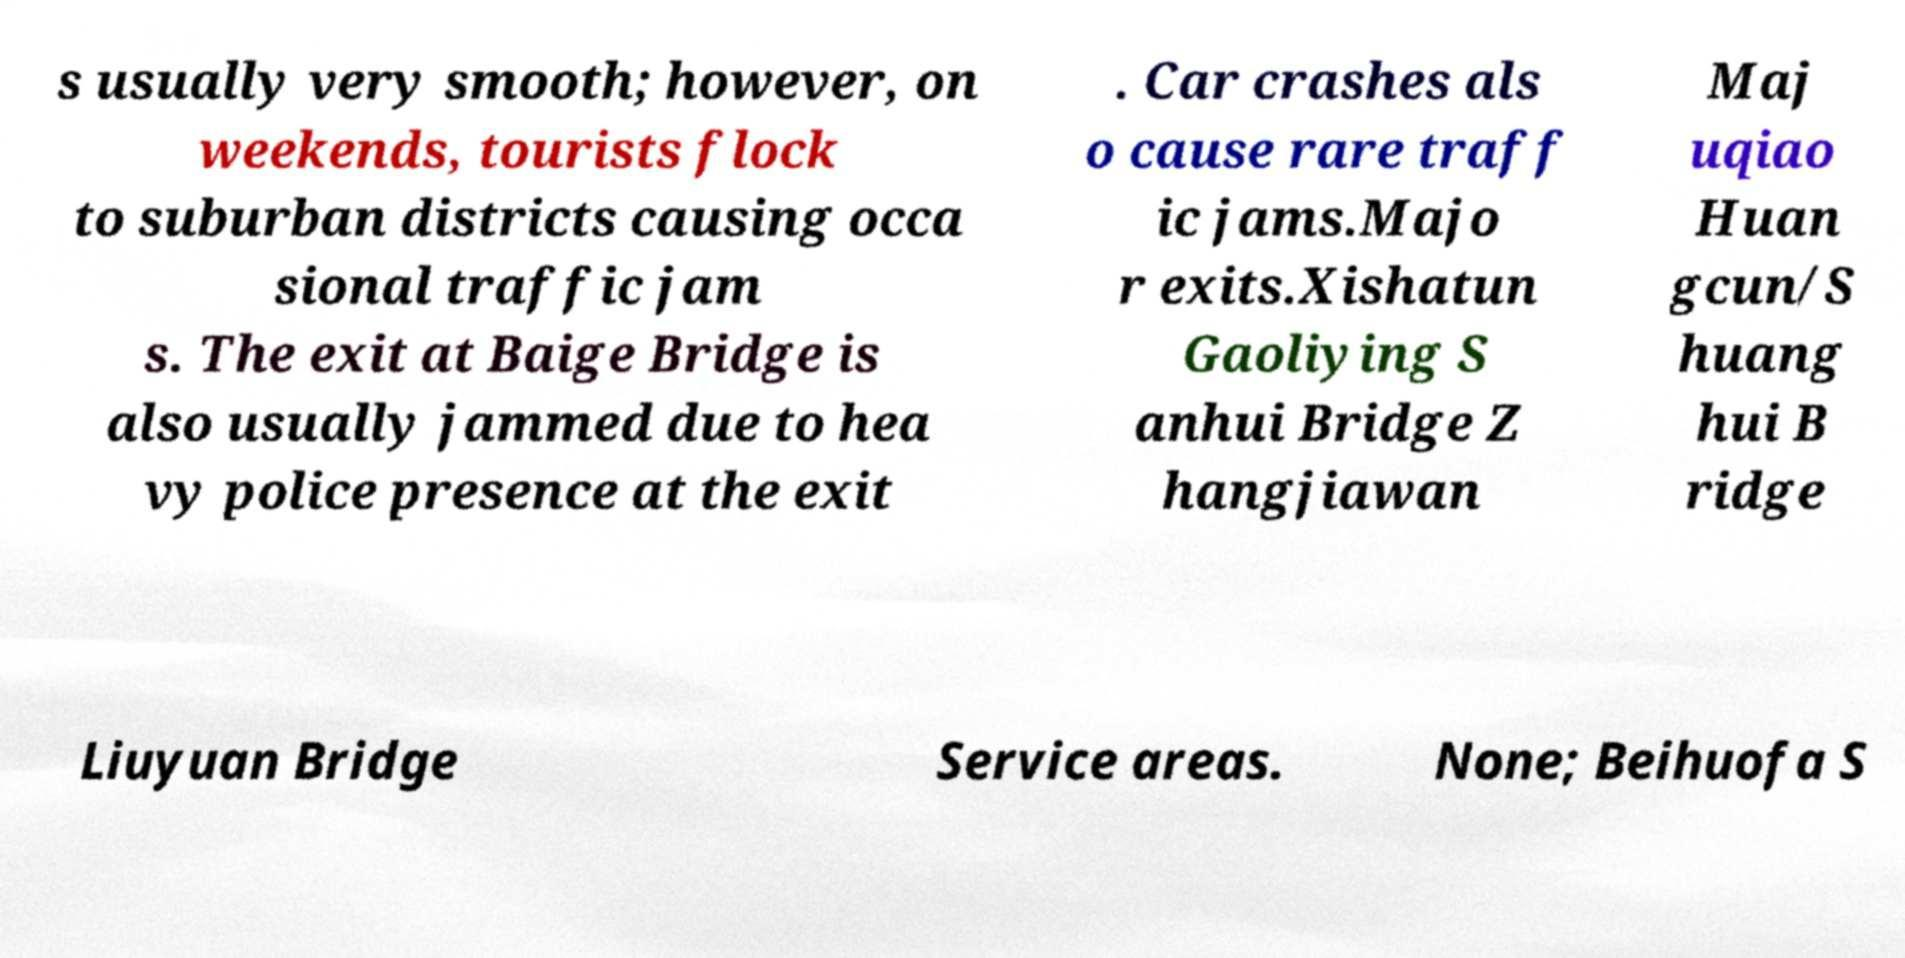Could you assist in decoding the text presented in this image and type it out clearly? s usually very smooth; however, on weekends, tourists flock to suburban districts causing occa sional traffic jam s. The exit at Baige Bridge is also usually jammed due to hea vy police presence at the exit . Car crashes als o cause rare traff ic jams.Majo r exits.Xishatun Gaoliying S anhui Bridge Z hangjiawan Maj uqiao Huan gcun/S huang hui B ridge Liuyuan Bridge Service areas. None; Beihuofa S 